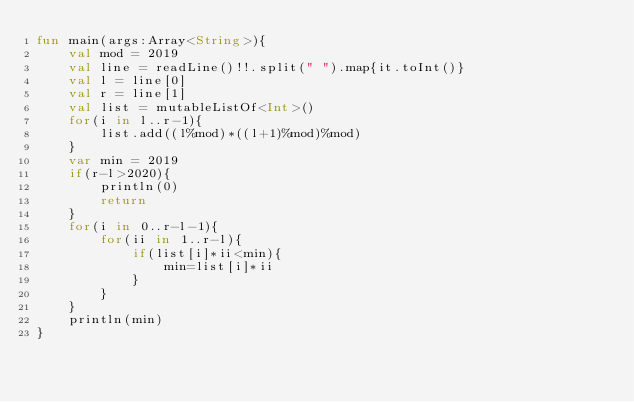Convert code to text. <code><loc_0><loc_0><loc_500><loc_500><_Kotlin_>fun main(args:Array<String>){
    val mod = 2019
    val line = readLine()!!.split(" ").map{it.toInt()}
    val l = line[0]
    val r = line[1]
    val list = mutableListOf<Int>()
    for(i in l..r-1){
        list.add((l%mod)*((l+1)%mod)%mod)
    }
    var min = 2019
    if(r-l>2020){
        println(0)
        return
    }
    for(i in 0..r-l-1){
        for(ii in 1..r-l){
            if(list[i]*ii<min){
                min=list[i]*ii
            }
        }
    }
    println(min)
}</code> 